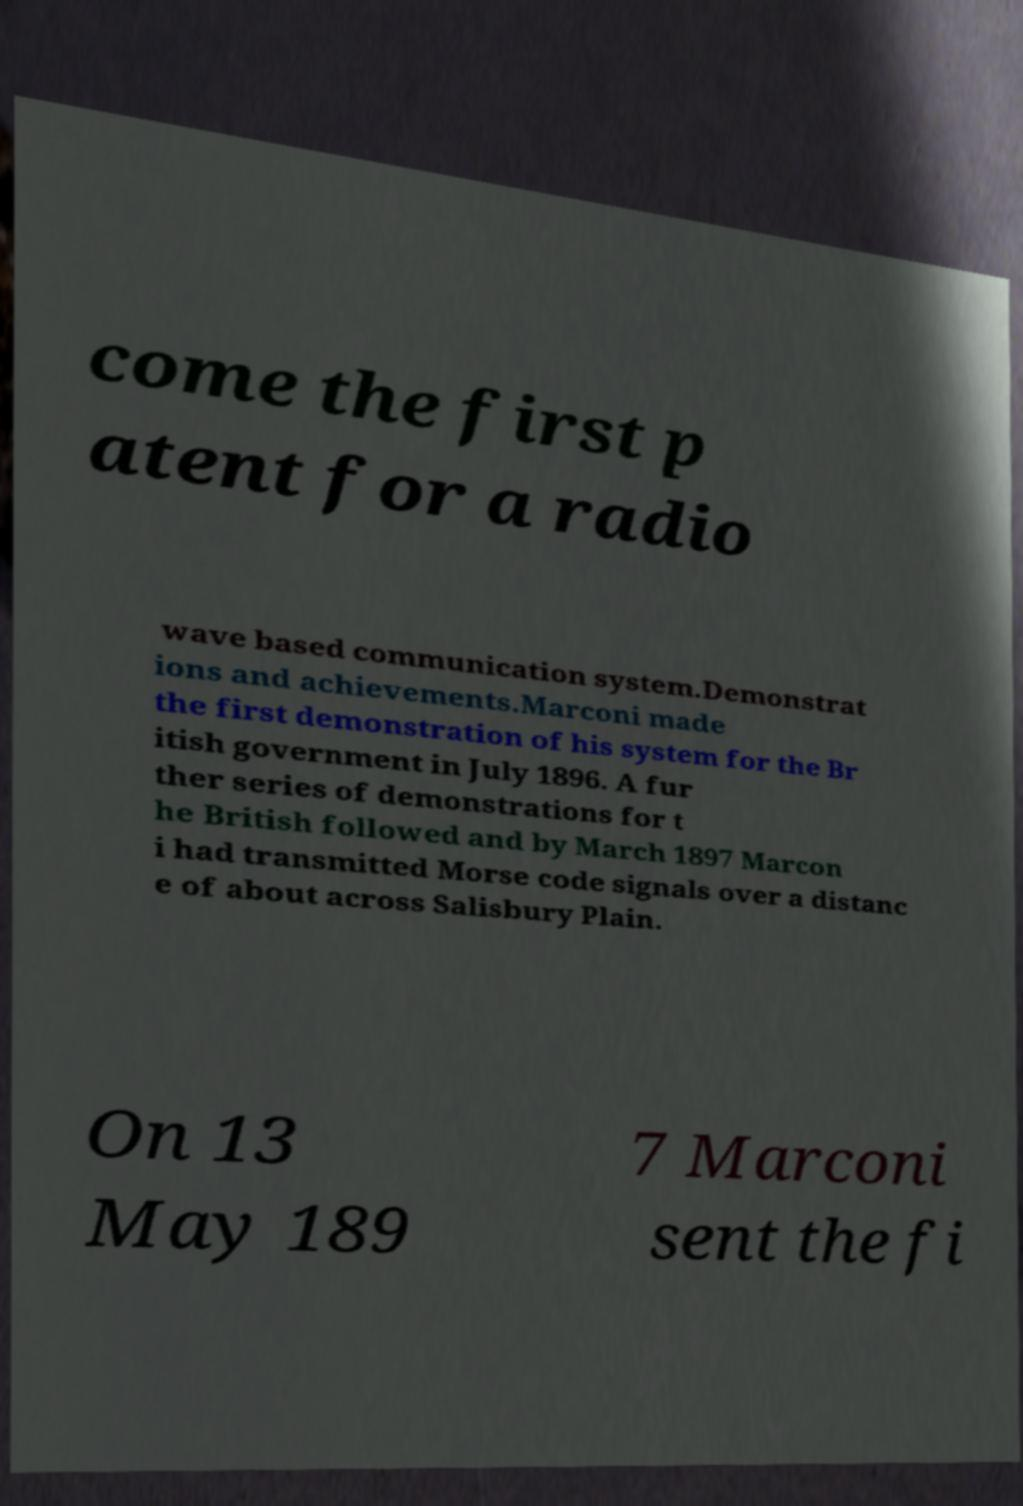Could you assist in decoding the text presented in this image and type it out clearly? come the first p atent for a radio wave based communication system.Demonstrat ions and achievements.Marconi made the first demonstration of his system for the Br itish government in July 1896. A fur ther series of demonstrations for t he British followed and by March 1897 Marcon i had transmitted Morse code signals over a distanc e of about across Salisbury Plain. On 13 May 189 7 Marconi sent the fi 